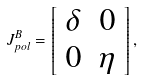Convert formula to latex. <formula><loc_0><loc_0><loc_500><loc_500>J _ { p o l } ^ { B } = \left [ \begin{array} { c c } \delta & 0 \\ 0 & \eta \end{array} \right ] ,</formula> 